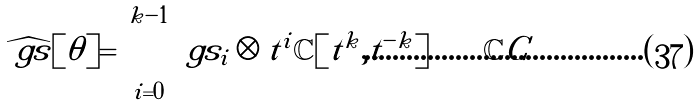<formula> <loc_0><loc_0><loc_500><loc_500>\widehat { \ g s } [ \theta ] = \bigoplus _ { i = 0 } ^ { k - 1 } \ g s _ { i } \otimes t ^ { i } \mathbb { C } [ t ^ { k } , t ^ { - k } ] \bigoplus \mathbb { C } C</formula> 